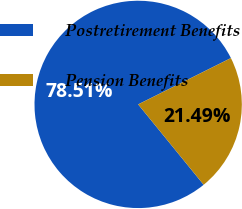Convert chart to OTSL. <chart><loc_0><loc_0><loc_500><loc_500><pie_chart><fcel>Postretirement Benefits<fcel>Pension Benefits<nl><fcel>78.51%<fcel>21.49%<nl></chart> 